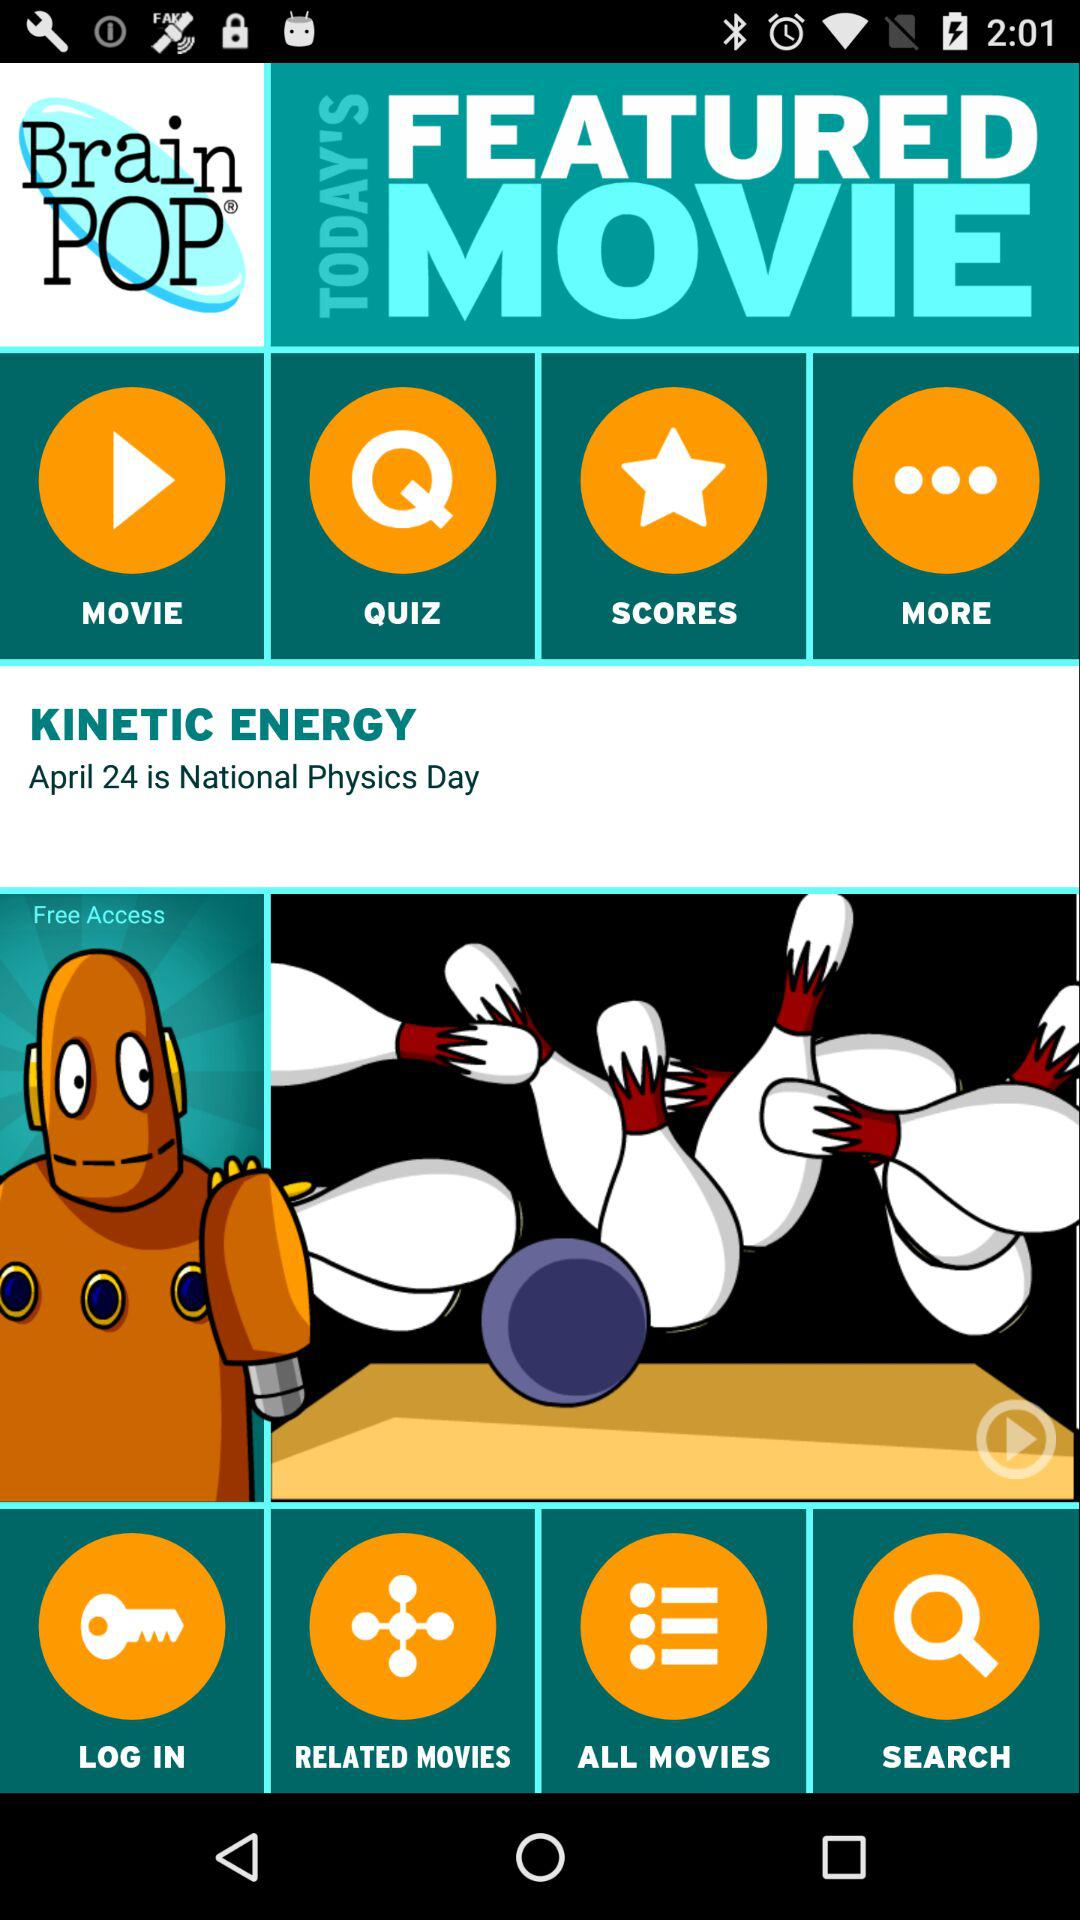When is National Physics Day? National Physics Day is on April 24. 